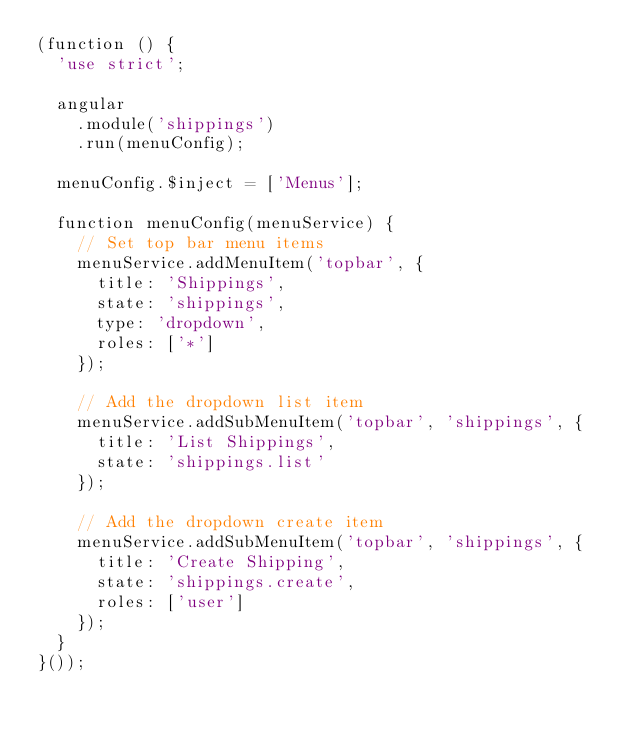<code> <loc_0><loc_0><loc_500><loc_500><_JavaScript_>(function () {
  'use strict';

  angular
    .module('shippings')
    .run(menuConfig);

  menuConfig.$inject = ['Menus'];

  function menuConfig(menuService) {
    // Set top bar menu items
    menuService.addMenuItem('topbar', {
      title: 'Shippings',
      state: 'shippings',
      type: 'dropdown',
      roles: ['*']
    });

    // Add the dropdown list item
    menuService.addSubMenuItem('topbar', 'shippings', {
      title: 'List Shippings',
      state: 'shippings.list'
    });

    // Add the dropdown create item
    menuService.addSubMenuItem('topbar', 'shippings', {
      title: 'Create Shipping',
      state: 'shippings.create',
      roles: ['user']
    });
  }
}());
</code> 